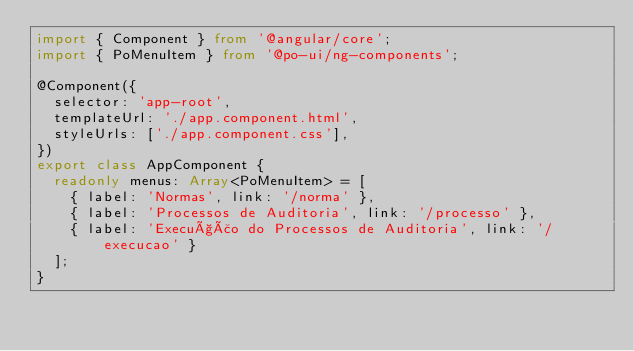Convert code to text. <code><loc_0><loc_0><loc_500><loc_500><_TypeScript_>import { Component } from '@angular/core';
import { PoMenuItem } from '@po-ui/ng-components';

@Component({
  selector: 'app-root',
  templateUrl: './app.component.html',
  styleUrls: ['./app.component.css'],
})
export class AppComponent {
  readonly menus: Array<PoMenuItem> = [
    { label: 'Normas', link: '/norma' },
    { label: 'Processos de Auditoria', link: '/processo' },
    { label: 'Execução do Processos de Auditoria', link: '/execucao' }
  ];
}</code> 